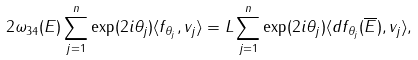Convert formula to latex. <formula><loc_0><loc_0><loc_500><loc_500>2 \omega _ { 3 4 } ( { E } ) \sum _ { j = 1 } ^ { n } \exp ( 2 i \theta _ { j } ) \langle f _ { \theta _ { j } } , v _ { j } \rangle = L \sum _ { j = 1 } ^ { n } \exp ( 2 i \theta _ { j } ) \langle d f _ { \theta _ { j } } ( \overline { E } ) , v _ { j } \rangle ,</formula> 